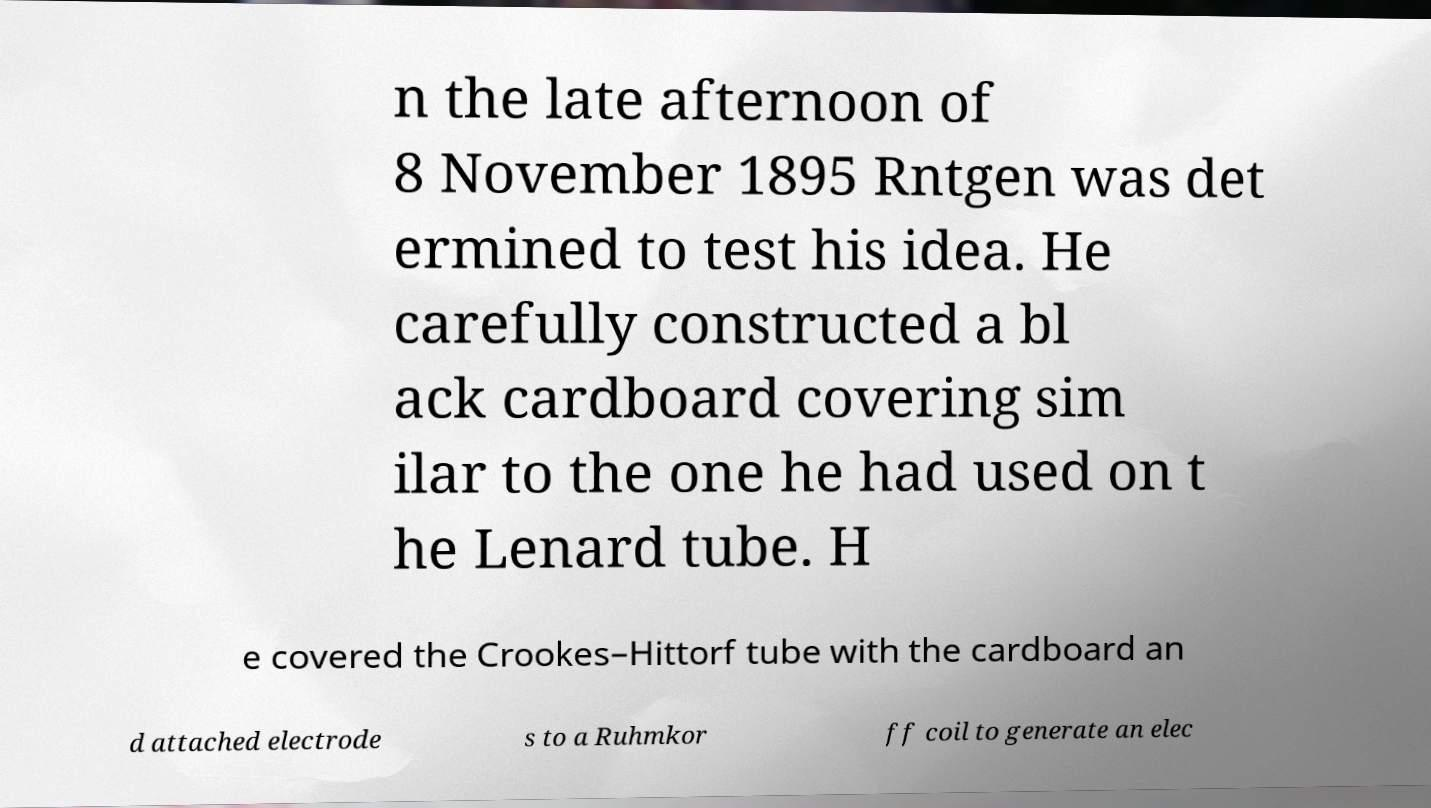Could you assist in decoding the text presented in this image and type it out clearly? n the late afternoon of 8 November 1895 Rntgen was det ermined to test his idea. He carefully constructed a bl ack cardboard covering sim ilar to the one he had used on t he Lenard tube. H e covered the Crookes–Hittorf tube with the cardboard an d attached electrode s to a Ruhmkor ff coil to generate an elec 